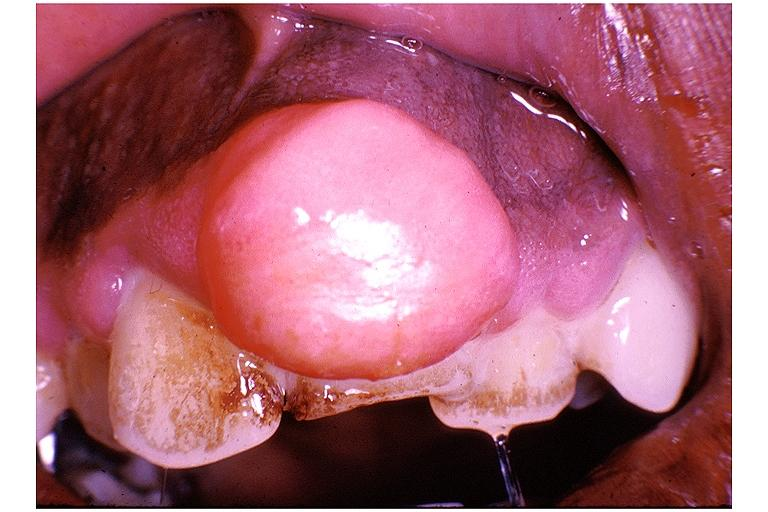s oral present?
Answer the question using a single word or phrase. Yes 